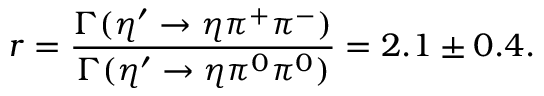<formula> <loc_0><loc_0><loc_500><loc_500>r = \frac { \Gamma ( \eta ^ { \prime } \rightarrow \eta \pi ^ { + } \pi ^ { - } ) } { \Gamma ( \eta ^ { \prime } \rightarrow \eta \pi ^ { 0 } \pi ^ { 0 } ) } = 2 . 1 \pm 0 . 4 .</formula> 